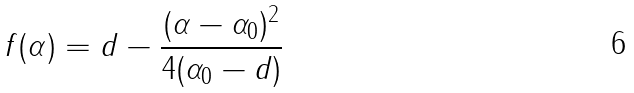<formula> <loc_0><loc_0><loc_500><loc_500>f ( \alpha ) = d - \frac { ( \alpha - \alpha _ { 0 } ) ^ { 2 } } { 4 ( \alpha _ { 0 } - d ) }</formula> 